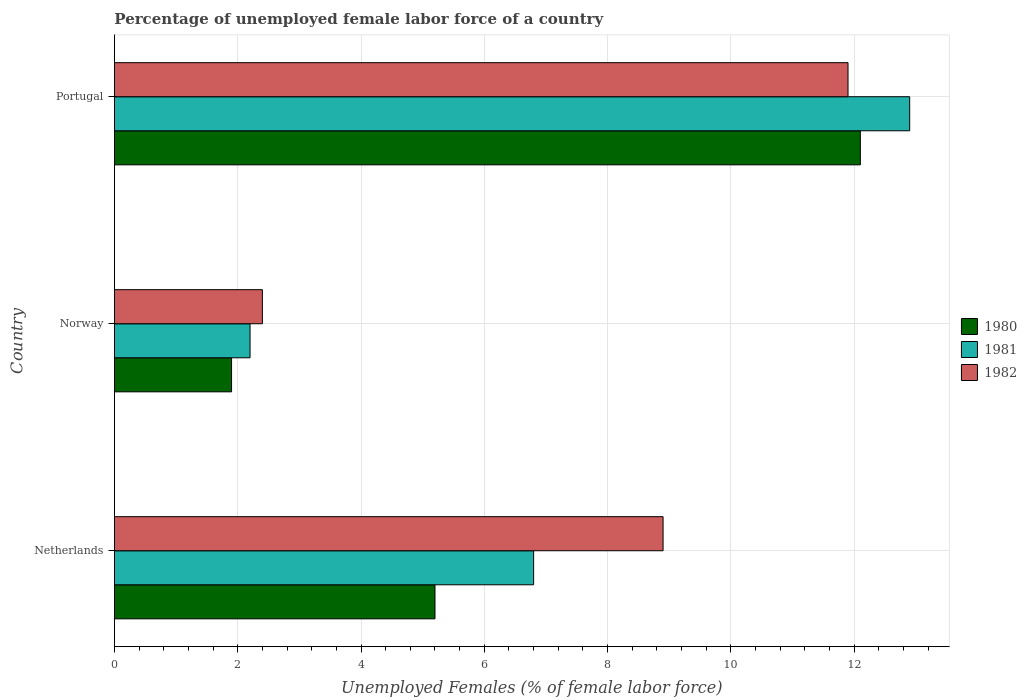How many different coloured bars are there?
Offer a very short reply. 3. How many groups of bars are there?
Give a very brief answer. 3. Are the number of bars on each tick of the Y-axis equal?
Make the answer very short. Yes. What is the label of the 2nd group of bars from the top?
Provide a succinct answer. Norway. What is the percentage of unemployed female labor force in 1982 in Portugal?
Offer a very short reply. 11.9. Across all countries, what is the maximum percentage of unemployed female labor force in 1981?
Your answer should be compact. 12.9. Across all countries, what is the minimum percentage of unemployed female labor force in 1980?
Your answer should be compact. 1.9. What is the total percentage of unemployed female labor force in 1981 in the graph?
Your response must be concise. 21.9. What is the difference between the percentage of unemployed female labor force in 1982 in Netherlands and that in Norway?
Your answer should be compact. 6.5. What is the difference between the percentage of unemployed female labor force in 1981 in Norway and the percentage of unemployed female labor force in 1982 in Portugal?
Your answer should be very brief. -9.7. What is the average percentage of unemployed female labor force in 1980 per country?
Keep it short and to the point. 6.4. What is the difference between the percentage of unemployed female labor force in 1981 and percentage of unemployed female labor force in 1980 in Netherlands?
Your response must be concise. 1.6. What is the ratio of the percentage of unemployed female labor force in 1981 in Netherlands to that in Norway?
Make the answer very short. 3.09. What is the difference between the highest and the second highest percentage of unemployed female labor force in 1980?
Offer a terse response. 6.9. What is the difference between the highest and the lowest percentage of unemployed female labor force in 1981?
Offer a terse response. 10.7. In how many countries, is the percentage of unemployed female labor force in 1982 greater than the average percentage of unemployed female labor force in 1982 taken over all countries?
Give a very brief answer. 2. What does the 3rd bar from the top in Norway represents?
Offer a terse response. 1980. What does the 2nd bar from the bottom in Portugal represents?
Make the answer very short. 1981. How many bars are there?
Make the answer very short. 9. Are the values on the major ticks of X-axis written in scientific E-notation?
Provide a succinct answer. No. Does the graph contain any zero values?
Ensure brevity in your answer.  No. What is the title of the graph?
Your answer should be very brief. Percentage of unemployed female labor force of a country. What is the label or title of the X-axis?
Provide a succinct answer. Unemployed Females (% of female labor force). What is the label or title of the Y-axis?
Provide a succinct answer. Country. What is the Unemployed Females (% of female labor force) in 1980 in Netherlands?
Offer a terse response. 5.2. What is the Unemployed Females (% of female labor force) in 1981 in Netherlands?
Make the answer very short. 6.8. What is the Unemployed Females (% of female labor force) in 1982 in Netherlands?
Give a very brief answer. 8.9. What is the Unemployed Females (% of female labor force) in 1980 in Norway?
Offer a very short reply. 1.9. What is the Unemployed Females (% of female labor force) in 1981 in Norway?
Give a very brief answer. 2.2. What is the Unemployed Females (% of female labor force) in 1982 in Norway?
Provide a succinct answer. 2.4. What is the Unemployed Females (% of female labor force) in 1980 in Portugal?
Ensure brevity in your answer.  12.1. What is the Unemployed Females (% of female labor force) of 1981 in Portugal?
Keep it short and to the point. 12.9. What is the Unemployed Females (% of female labor force) of 1982 in Portugal?
Make the answer very short. 11.9. Across all countries, what is the maximum Unemployed Females (% of female labor force) of 1980?
Provide a succinct answer. 12.1. Across all countries, what is the maximum Unemployed Females (% of female labor force) of 1981?
Make the answer very short. 12.9. Across all countries, what is the maximum Unemployed Females (% of female labor force) of 1982?
Ensure brevity in your answer.  11.9. Across all countries, what is the minimum Unemployed Females (% of female labor force) of 1980?
Give a very brief answer. 1.9. Across all countries, what is the minimum Unemployed Females (% of female labor force) of 1981?
Give a very brief answer. 2.2. Across all countries, what is the minimum Unemployed Females (% of female labor force) of 1982?
Offer a very short reply. 2.4. What is the total Unemployed Females (% of female labor force) of 1981 in the graph?
Keep it short and to the point. 21.9. What is the total Unemployed Females (% of female labor force) in 1982 in the graph?
Your answer should be very brief. 23.2. What is the difference between the Unemployed Females (% of female labor force) in 1982 in Netherlands and that in Norway?
Your answer should be very brief. 6.5. What is the difference between the Unemployed Females (% of female labor force) in 1981 in Netherlands and that in Portugal?
Provide a succinct answer. -6.1. What is the difference between the Unemployed Females (% of female labor force) in 1980 in Norway and that in Portugal?
Provide a succinct answer. -10.2. What is the difference between the Unemployed Females (% of female labor force) in 1981 in Norway and that in Portugal?
Provide a short and direct response. -10.7. What is the difference between the Unemployed Females (% of female labor force) of 1980 in Netherlands and the Unemployed Females (% of female labor force) of 1981 in Norway?
Provide a short and direct response. 3. What is the difference between the Unemployed Females (% of female labor force) in 1981 in Netherlands and the Unemployed Females (% of female labor force) in 1982 in Norway?
Make the answer very short. 4.4. What is the difference between the Unemployed Females (% of female labor force) in 1980 in Norway and the Unemployed Females (% of female labor force) in 1981 in Portugal?
Ensure brevity in your answer.  -11. What is the difference between the Unemployed Females (% of female labor force) of 1980 in Norway and the Unemployed Females (% of female labor force) of 1982 in Portugal?
Your answer should be compact. -10. What is the difference between the Unemployed Females (% of female labor force) of 1981 in Norway and the Unemployed Females (% of female labor force) of 1982 in Portugal?
Give a very brief answer. -9.7. What is the average Unemployed Females (% of female labor force) of 1981 per country?
Your response must be concise. 7.3. What is the average Unemployed Females (% of female labor force) in 1982 per country?
Provide a succinct answer. 7.73. What is the difference between the Unemployed Females (% of female labor force) of 1980 and Unemployed Females (% of female labor force) of 1982 in Netherlands?
Offer a terse response. -3.7. What is the difference between the Unemployed Females (% of female labor force) in 1981 and Unemployed Females (% of female labor force) in 1982 in Netherlands?
Offer a terse response. -2.1. What is the difference between the Unemployed Females (% of female labor force) in 1980 and Unemployed Females (% of female labor force) in 1981 in Norway?
Provide a short and direct response. -0.3. What is the difference between the Unemployed Females (% of female labor force) in 1980 and Unemployed Females (% of female labor force) in 1981 in Portugal?
Ensure brevity in your answer.  -0.8. What is the difference between the Unemployed Females (% of female labor force) in 1980 and Unemployed Females (% of female labor force) in 1982 in Portugal?
Your answer should be compact. 0.2. What is the difference between the Unemployed Females (% of female labor force) of 1981 and Unemployed Females (% of female labor force) of 1982 in Portugal?
Your answer should be compact. 1. What is the ratio of the Unemployed Females (% of female labor force) in 1980 in Netherlands to that in Norway?
Provide a short and direct response. 2.74. What is the ratio of the Unemployed Females (% of female labor force) in 1981 in Netherlands to that in Norway?
Your answer should be compact. 3.09. What is the ratio of the Unemployed Females (% of female labor force) of 1982 in Netherlands to that in Norway?
Your answer should be very brief. 3.71. What is the ratio of the Unemployed Females (% of female labor force) in 1980 in Netherlands to that in Portugal?
Ensure brevity in your answer.  0.43. What is the ratio of the Unemployed Females (% of female labor force) of 1981 in Netherlands to that in Portugal?
Offer a terse response. 0.53. What is the ratio of the Unemployed Females (% of female labor force) in 1982 in Netherlands to that in Portugal?
Your answer should be very brief. 0.75. What is the ratio of the Unemployed Females (% of female labor force) in 1980 in Norway to that in Portugal?
Your answer should be very brief. 0.16. What is the ratio of the Unemployed Females (% of female labor force) in 1981 in Norway to that in Portugal?
Make the answer very short. 0.17. What is the ratio of the Unemployed Females (% of female labor force) in 1982 in Norway to that in Portugal?
Your response must be concise. 0.2. What is the difference between the highest and the second highest Unemployed Females (% of female labor force) in 1981?
Provide a short and direct response. 6.1. What is the difference between the highest and the second highest Unemployed Females (% of female labor force) of 1982?
Ensure brevity in your answer.  3. 